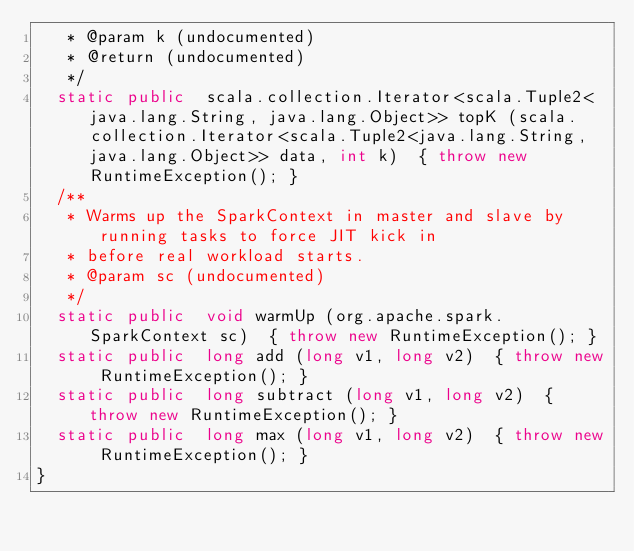<code> <loc_0><loc_0><loc_500><loc_500><_Java_>   * @param k (undocumented)
   * @return (undocumented)
   */
  static public  scala.collection.Iterator<scala.Tuple2<java.lang.String, java.lang.Object>> topK (scala.collection.Iterator<scala.Tuple2<java.lang.String, java.lang.Object>> data, int k)  { throw new RuntimeException(); }
  /**
   * Warms up the SparkContext in master and slave by running tasks to force JIT kick in
   * before real workload starts.
   * @param sc (undocumented)
   */
  static public  void warmUp (org.apache.spark.SparkContext sc)  { throw new RuntimeException(); }
  static public  long add (long v1, long v2)  { throw new RuntimeException(); }
  static public  long subtract (long v1, long v2)  { throw new RuntimeException(); }
  static public  long max (long v1, long v2)  { throw new RuntimeException(); }
}
</code> 